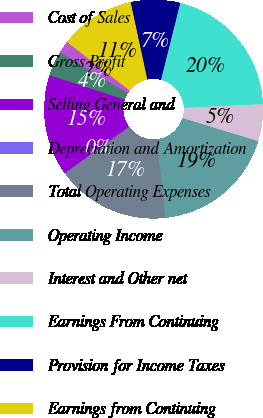<chart> <loc_0><loc_0><loc_500><loc_500><pie_chart><fcel>Cost of Sales<fcel>Gross Profit<fcel>Selling General and<fcel>Depreciation and Amortization<fcel>Total Operating Expenses<fcel>Operating Income<fcel>Interest and Other net<fcel>Earnings From Continuing<fcel>Provision for Income Taxes<fcel>Earnings from Continuing<nl><fcel>1.86%<fcel>3.66%<fcel>14.93%<fcel>0.05%<fcel>16.74%<fcel>18.54%<fcel>5.47%<fcel>20.35%<fcel>7.28%<fcel>11.12%<nl></chart> 